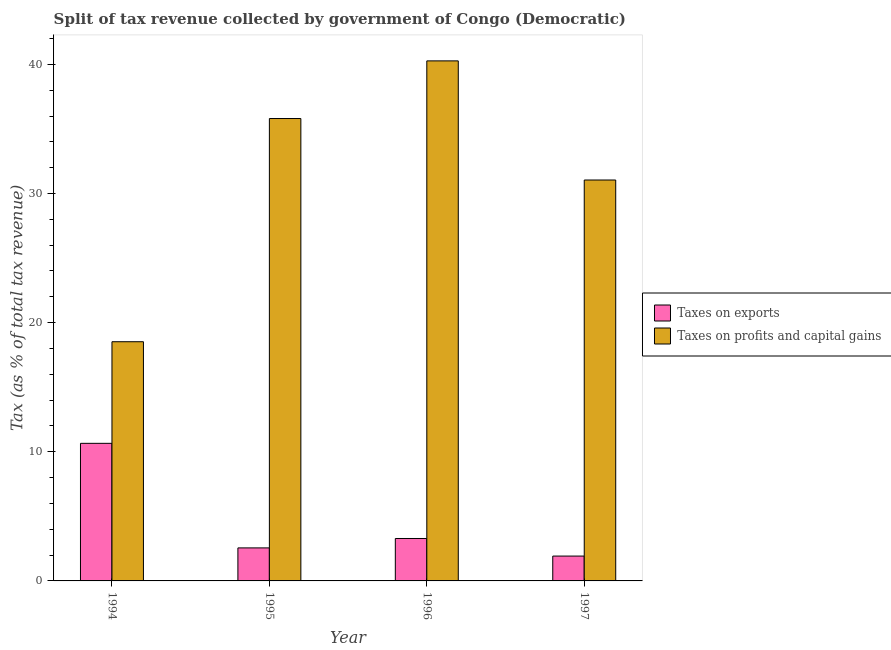Are the number of bars per tick equal to the number of legend labels?
Offer a terse response. Yes. What is the label of the 4th group of bars from the left?
Keep it short and to the point. 1997. In how many cases, is the number of bars for a given year not equal to the number of legend labels?
Your response must be concise. 0. What is the percentage of revenue obtained from taxes on exports in 1994?
Your answer should be very brief. 10.65. Across all years, what is the maximum percentage of revenue obtained from taxes on profits and capital gains?
Offer a very short reply. 40.27. Across all years, what is the minimum percentage of revenue obtained from taxes on exports?
Make the answer very short. 1.92. In which year was the percentage of revenue obtained from taxes on exports maximum?
Your answer should be compact. 1994. What is the total percentage of revenue obtained from taxes on profits and capital gains in the graph?
Make the answer very short. 125.64. What is the difference between the percentage of revenue obtained from taxes on exports in 1995 and that in 1996?
Your answer should be compact. -0.73. What is the difference between the percentage of revenue obtained from taxes on profits and capital gains in 1994 and the percentage of revenue obtained from taxes on exports in 1996?
Provide a short and direct response. -21.75. What is the average percentage of revenue obtained from taxes on profits and capital gains per year?
Offer a very short reply. 31.41. In the year 1996, what is the difference between the percentage of revenue obtained from taxes on exports and percentage of revenue obtained from taxes on profits and capital gains?
Your answer should be very brief. 0. In how many years, is the percentage of revenue obtained from taxes on profits and capital gains greater than 22 %?
Offer a very short reply. 3. What is the ratio of the percentage of revenue obtained from taxes on exports in 1994 to that in 1997?
Your response must be concise. 5.54. What is the difference between the highest and the second highest percentage of revenue obtained from taxes on profits and capital gains?
Keep it short and to the point. 4.46. What is the difference between the highest and the lowest percentage of revenue obtained from taxes on exports?
Your answer should be compact. 8.73. In how many years, is the percentage of revenue obtained from taxes on profits and capital gains greater than the average percentage of revenue obtained from taxes on profits and capital gains taken over all years?
Make the answer very short. 2. What does the 2nd bar from the left in 1995 represents?
Your response must be concise. Taxes on profits and capital gains. What does the 1st bar from the right in 1996 represents?
Offer a terse response. Taxes on profits and capital gains. Are the values on the major ticks of Y-axis written in scientific E-notation?
Offer a terse response. No. How are the legend labels stacked?
Make the answer very short. Vertical. What is the title of the graph?
Your answer should be very brief. Split of tax revenue collected by government of Congo (Democratic). Does "Primary income" appear as one of the legend labels in the graph?
Make the answer very short. No. What is the label or title of the Y-axis?
Keep it short and to the point. Tax (as % of total tax revenue). What is the Tax (as % of total tax revenue) of Taxes on exports in 1994?
Your answer should be very brief. 10.65. What is the Tax (as % of total tax revenue) in Taxes on profits and capital gains in 1994?
Your response must be concise. 18.52. What is the Tax (as % of total tax revenue) of Taxes on exports in 1995?
Your answer should be very brief. 2.56. What is the Tax (as % of total tax revenue) of Taxes on profits and capital gains in 1995?
Make the answer very short. 35.81. What is the Tax (as % of total tax revenue) in Taxes on exports in 1996?
Offer a very short reply. 3.29. What is the Tax (as % of total tax revenue) of Taxes on profits and capital gains in 1996?
Provide a short and direct response. 40.27. What is the Tax (as % of total tax revenue) in Taxes on exports in 1997?
Your answer should be very brief. 1.92. What is the Tax (as % of total tax revenue) in Taxes on profits and capital gains in 1997?
Provide a short and direct response. 31.05. Across all years, what is the maximum Tax (as % of total tax revenue) of Taxes on exports?
Offer a terse response. 10.65. Across all years, what is the maximum Tax (as % of total tax revenue) in Taxes on profits and capital gains?
Make the answer very short. 40.27. Across all years, what is the minimum Tax (as % of total tax revenue) of Taxes on exports?
Give a very brief answer. 1.92. Across all years, what is the minimum Tax (as % of total tax revenue) of Taxes on profits and capital gains?
Your response must be concise. 18.52. What is the total Tax (as % of total tax revenue) of Taxes on exports in the graph?
Offer a terse response. 18.42. What is the total Tax (as % of total tax revenue) in Taxes on profits and capital gains in the graph?
Your answer should be compact. 125.64. What is the difference between the Tax (as % of total tax revenue) of Taxes on exports in 1994 and that in 1995?
Provide a succinct answer. 8.1. What is the difference between the Tax (as % of total tax revenue) of Taxes on profits and capital gains in 1994 and that in 1995?
Ensure brevity in your answer.  -17.28. What is the difference between the Tax (as % of total tax revenue) of Taxes on exports in 1994 and that in 1996?
Make the answer very short. 7.37. What is the difference between the Tax (as % of total tax revenue) in Taxes on profits and capital gains in 1994 and that in 1996?
Ensure brevity in your answer.  -21.75. What is the difference between the Tax (as % of total tax revenue) in Taxes on exports in 1994 and that in 1997?
Ensure brevity in your answer.  8.73. What is the difference between the Tax (as % of total tax revenue) in Taxes on profits and capital gains in 1994 and that in 1997?
Provide a succinct answer. -12.52. What is the difference between the Tax (as % of total tax revenue) in Taxes on exports in 1995 and that in 1996?
Keep it short and to the point. -0.73. What is the difference between the Tax (as % of total tax revenue) in Taxes on profits and capital gains in 1995 and that in 1996?
Give a very brief answer. -4.46. What is the difference between the Tax (as % of total tax revenue) of Taxes on exports in 1995 and that in 1997?
Give a very brief answer. 0.63. What is the difference between the Tax (as % of total tax revenue) of Taxes on profits and capital gains in 1995 and that in 1997?
Your answer should be compact. 4.76. What is the difference between the Tax (as % of total tax revenue) in Taxes on exports in 1996 and that in 1997?
Offer a very short reply. 1.36. What is the difference between the Tax (as % of total tax revenue) in Taxes on profits and capital gains in 1996 and that in 1997?
Make the answer very short. 9.22. What is the difference between the Tax (as % of total tax revenue) in Taxes on exports in 1994 and the Tax (as % of total tax revenue) in Taxes on profits and capital gains in 1995?
Provide a succinct answer. -25.15. What is the difference between the Tax (as % of total tax revenue) of Taxes on exports in 1994 and the Tax (as % of total tax revenue) of Taxes on profits and capital gains in 1996?
Provide a short and direct response. -29.62. What is the difference between the Tax (as % of total tax revenue) in Taxes on exports in 1994 and the Tax (as % of total tax revenue) in Taxes on profits and capital gains in 1997?
Your answer should be very brief. -20.39. What is the difference between the Tax (as % of total tax revenue) in Taxes on exports in 1995 and the Tax (as % of total tax revenue) in Taxes on profits and capital gains in 1996?
Keep it short and to the point. -37.71. What is the difference between the Tax (as % of total tax revenue) of Taxes on exports in 1995 and the Tax (as % of total tax revenue) of Taxes on profits and capital gains in 1997?
Your answer should be very brief. -28.49. What is the difference between the Tax (as % of total tax revenue) in Taxes on exports in 1996 and the Tax (as % of total tax revenue) in Taxes on profits and capital gains in 1997?
Your answer should be compact. -27.76. What is the average Tax (as % of total tax revenue) in Taxes on exports per year?
Offer a terse response. 4.61. What is the average Tax (as % of total tax revenue) of Taxes on profits and capital gains per year?
Offer a very short reply. 31.41. In the year 1994, what is the difference between the Tax (as % of total tax revenue) in Taxes on exports and Tax (as % of total tax revenue) in Taxes on profits and capital gains?
Your answer should be very brief. -7.87. In the year 1995, what is the difference between the Tax (as % of total tax revenue) in Taxes on exports and Tax (as % of total tax revenue) in Taxes on profits and capital gains?
Offer a very short reply. -33.25. In the year 1996, what is the difference between the Tax (as % of total tax revenue) of Taxes on exports and Tax (as % of total tax revenue) of Taxes on profits and capital gains?
Your answer should be compact. -36.98. In the year 1997, what is the difference between the Tax (as % of total tax revenue) in Taxes on exports and Tax (as % of total tax revenue) in Taxes on profits and capital gains?
Your answer should be compact. -29.12. What is the ratio of the Tax (as % of total tax revenue) in Taxes on exports in 1994 to that in 1995?
Provide a short and direct response. 4.17. What is the ratio of the Tax (as % of total tax revenue) of Taxes on profits and capital gains in 1994 to that in 1995?
Your answer should be compact. 0.52. What is the ratio of the Tax (as % of total tax revenue) in Taxes on exports in 1994 to that in 1996?
Provide a short and direct response. 3.24. What is the ratio of the Tax (as % of total tax revenue) of Taxes on profits and capital gains in 1994 to that in 1996?
Give a very brief answer. 0.46. What is the ratio of the Tax (as % of total tax revenue) in Taxes on exports in 1994 to that in 1997?
Keep it short and to the point. 5.54. What is the ratio of the Tax (as % of total tax revenue) in Taxes on profits and capital gains in 1994 to that in 1997?
Keep it short and to the point. 0.6. What is the ratio of the Tax (as % of total tax revenue) of Taxes on exports in 1995 to that in 1996?
Offer a terse response. 0.78. What is the ratio of the Tax (as % of total tax revenue) in Taxes on profits and capital gains in 1995 to that in 1996?
Your answer should be very brief. 0.89. What is the ratio of the Tax (as % of total tax revenue) of Taxes on exports in 1995 to that in 1997?
Provide a succinct answer. 1.33. What is the ratio of the Tax (as % of total tax revenue) of Taxes on profits and capital gains in 1995 to that in 1997?
Your response must be concise. 1.15. What is the ratio of the Tax (as % of total tax revenue) in Taxes on exports in 1996 to that in 1997?
Offer a very short reply. 1.71. What is the ratio of the Tax (as % of total tax revenue) of Taxes on profits and capital gains in 1996 to that in 1997?
Your answer should be very brief. 1.3. What is the difference between the highest and the second highest Tax (as % of total tax revenue) of Taxes on exports?
Your answer should be compact. 7.37. What is the difference between the highest and the second highest Tax (as % of total tax revenue) of Taxes on profits and capital gains?
Make the answer very short. 4.46. What is the difference between the highest and the lowest Tax (as % of total tax revenue) in Taxes on exports?
Provide a succinct answer. 8.73. What is the difference between the highest and the lowest Tax (as % of total tax revenue) of Taxes on profits and capital gains?
Offer a terse response. 21.75. 